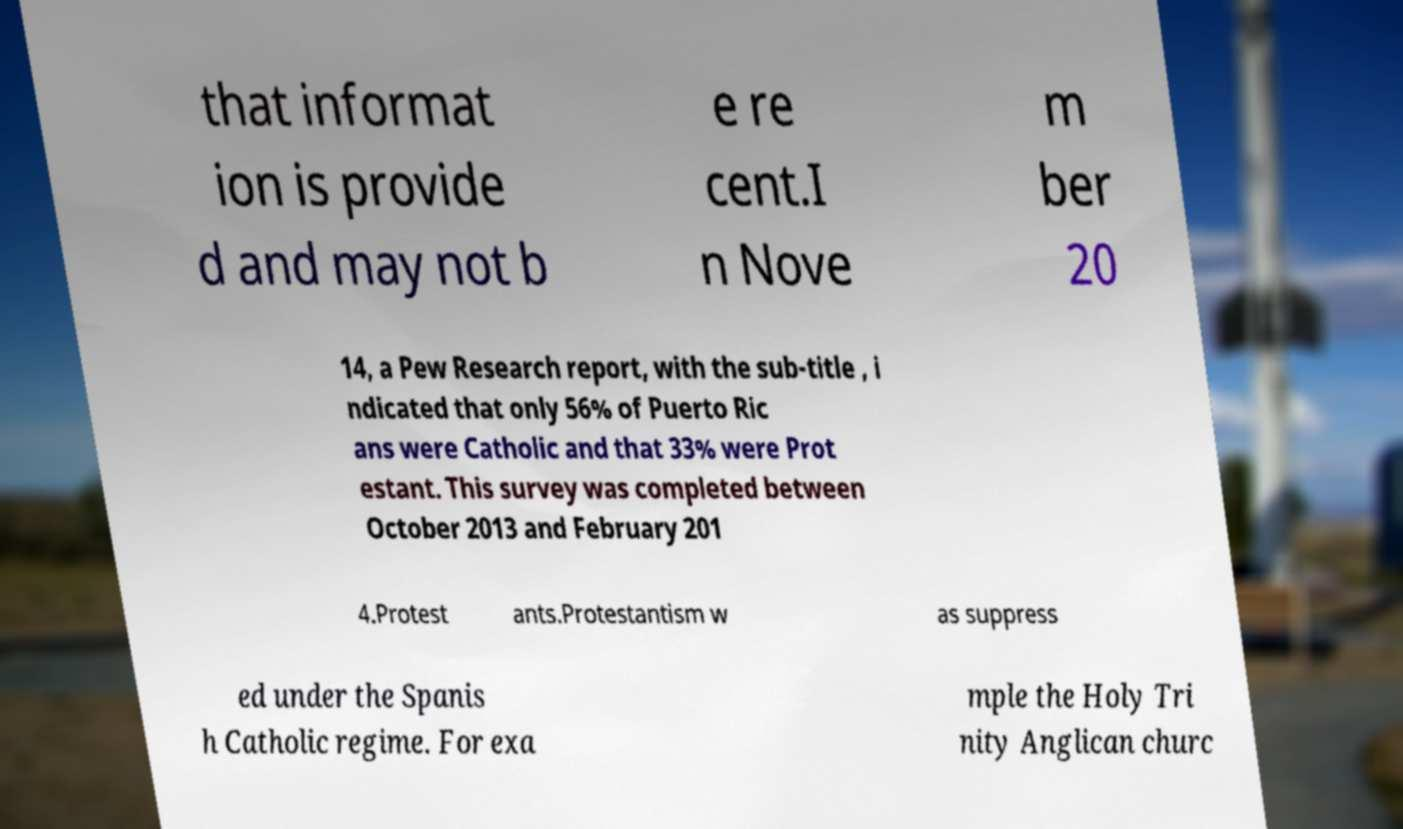For documentation purposes, I need the text within this image transcribed. Could you provide that? that informat ion is provide d and may not b e re cent.I n Nove m ber 20 14, a Pew Research report, with the sub-title , i ndicated that only 56% of Puerto Ric ans were Catholic and that 33% were Prot estant. This survey was completed between October 2013 and February 201 4.Protest ants.Protestantism w as suppress ed under the Spanis h Catholic regime. For exa mple the Holy Tri nity Anglican churc 